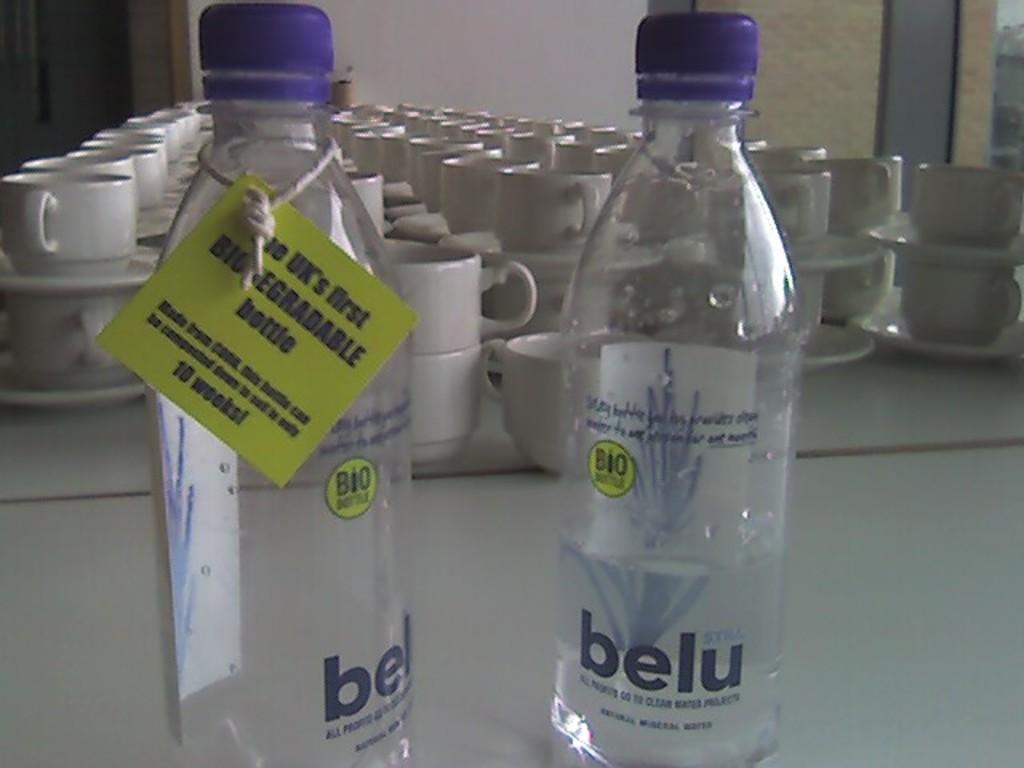Can we recycle that bottle?
Give a very brief answer. Yes. 